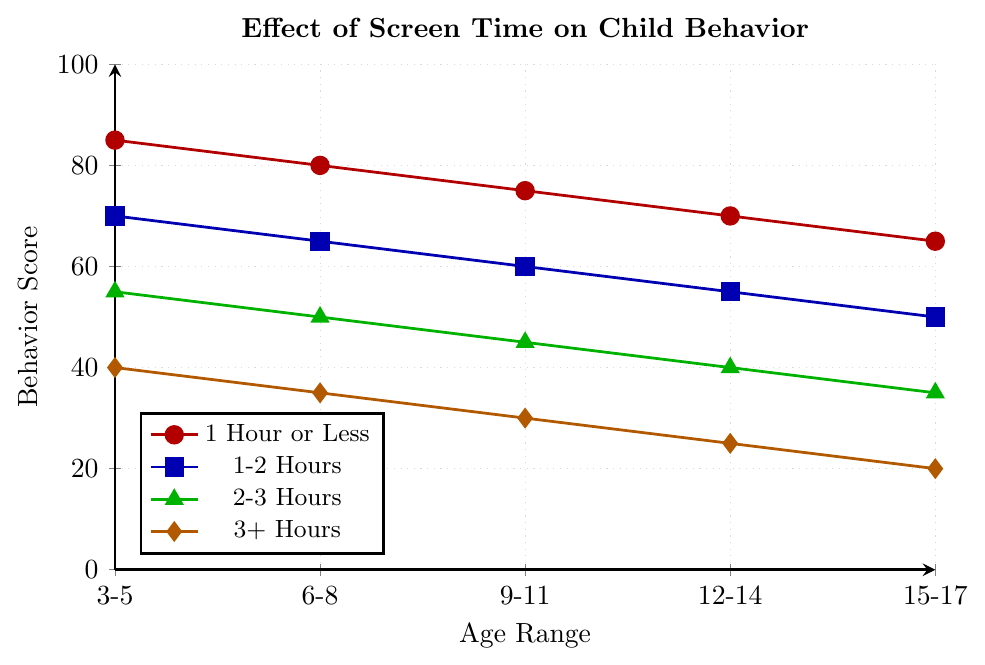Which age range has the highest behavior score for the '1-2 Hours' screen time limit? Look at the blue line labeled '1-2 Hours' and determine the highest point on the chart, which represents the score. The highest score is 70, located in the 3-5 years age range.
Answer: 3-5 years Compare the behavior scores for the '1 Hour or Less' and '2-3 Hours' screen time limits for children aged 6-8 years. Which is higher and by how much? The red line ('1 Hour or Less') scores 80 for the 6-8 years age range. The green line ('2-3 Hours') scores 50 for the same age range. The difference is 80 - 50 = 30.
Answer: 1 Hour or Less, higher by 30 For ages 15-17, what is the difference in behavior scores between children who have '1 Hour or Less' and those who have '3+ Hours' of screen time? The red line ('1 Hour or Less') shows a score of 65 for 15-17 years. The orange line ('3+ Hours') shows a score of 20 for the same age range. The difference is 65 - 20 = 45.
Answer: 45 As children get older, how does the behavior score change with '3+ Hours' of screen time? Starting from 3-5 years (score 40) to 15-17 years (score 20), the behavior score decreases as the age range increases.
Answer: Decreases What is the average behavior score for the '2-3 Hours' screen time limit across all age ranges? Sum the scores shown by the green line: 55 (3-5 years) + 50 (6-8 years) + 45 (9-11 years) + 40 (12-14 years) + 35 (15-17 years) = 225. Divide by the number of age ranges (5). 225 / 5 = 45.
Answer: 45 Which two age ranges have the least difference in behavior scores for the '1-2 Hours' screen time limit? Look at the blue line to identify the smallest difference between points: from 3-5 years (70) to 6-8 years (65), the difference is 70 - 65 = 5, which is the smallest.
Answer: 3-5 years and 6-8 years How much lower is the behavior score for '3+ Hours' of screen time compared to '1 Hour or Less' for children aged 9-11 years? The score for '3+ Hours' (orange line) is 30, and the score for '1 Hour or Less' (red line) is 75. The difference is 75 - 30 = 45.
Answer: 45 What is the average difference in behavior scores between '1 Hour or Less' and '1-2 Hours' of screen time across all age ranges? Calculate the differences for each age range: 
3-5 years: 85 - 70 = 15,
6-8 years: 80 - 65 = 15,
9-11 years: 75 - 60 = 15,
12-14 years: 70 - 55 = 15,
15-17 years: 65 - 50 = 15.
Sum these differences: 15 + 15 + 15 + 15 + 15 = 75.
Average: 75 / 5 = 15.
Answer: 15 